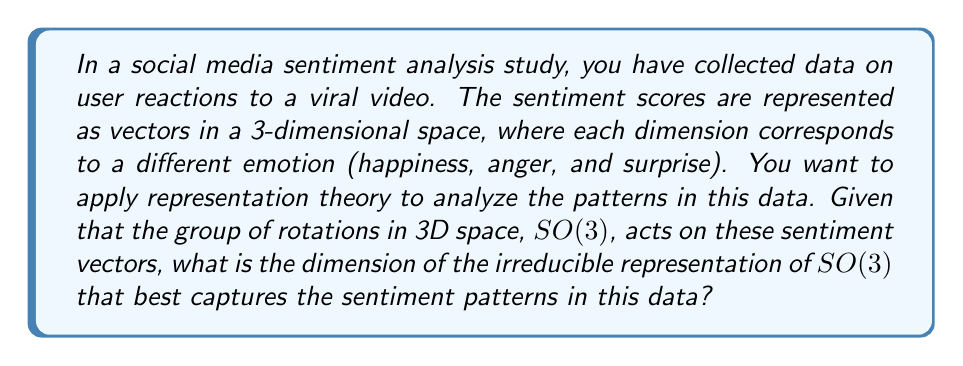Help me with this question. To solve this problem, we need to follow these steps:

1) First, recall that the sentiment vectors are in a 3-dimensional space. This means we are dealing with the natural representation of SO(3) on $\mathbb{R}^3$.

2) In representation theory, it's known that the natural representation of SO(3) on $\mathbb{R}^3$ is irreducible. This means it cannot be decomposed into smaller invariant subspaces.

3) The dimension of an irreducible representation is the dimension of the vector space on which it acts. In this case, that's $\mathbb{R}^3$.

4) Therefore, the dimension of the irreducible representation that best captures the sentiment patterns is 3.

5) This 3-dimensional irreducible representation allows us to capture the full complexity of the sentiment patterns in the 3D emotion space (happiness, anger, surprise) without losing any information through projection onto lower-dimensional subspaces.

6) In the context of sentiment analysis in social media, this means that all three emotional dimensions are necessary to fully describe the sentiment patterns, and no simpler representation can adequately capture the complexity of the data.
Answer: 3 